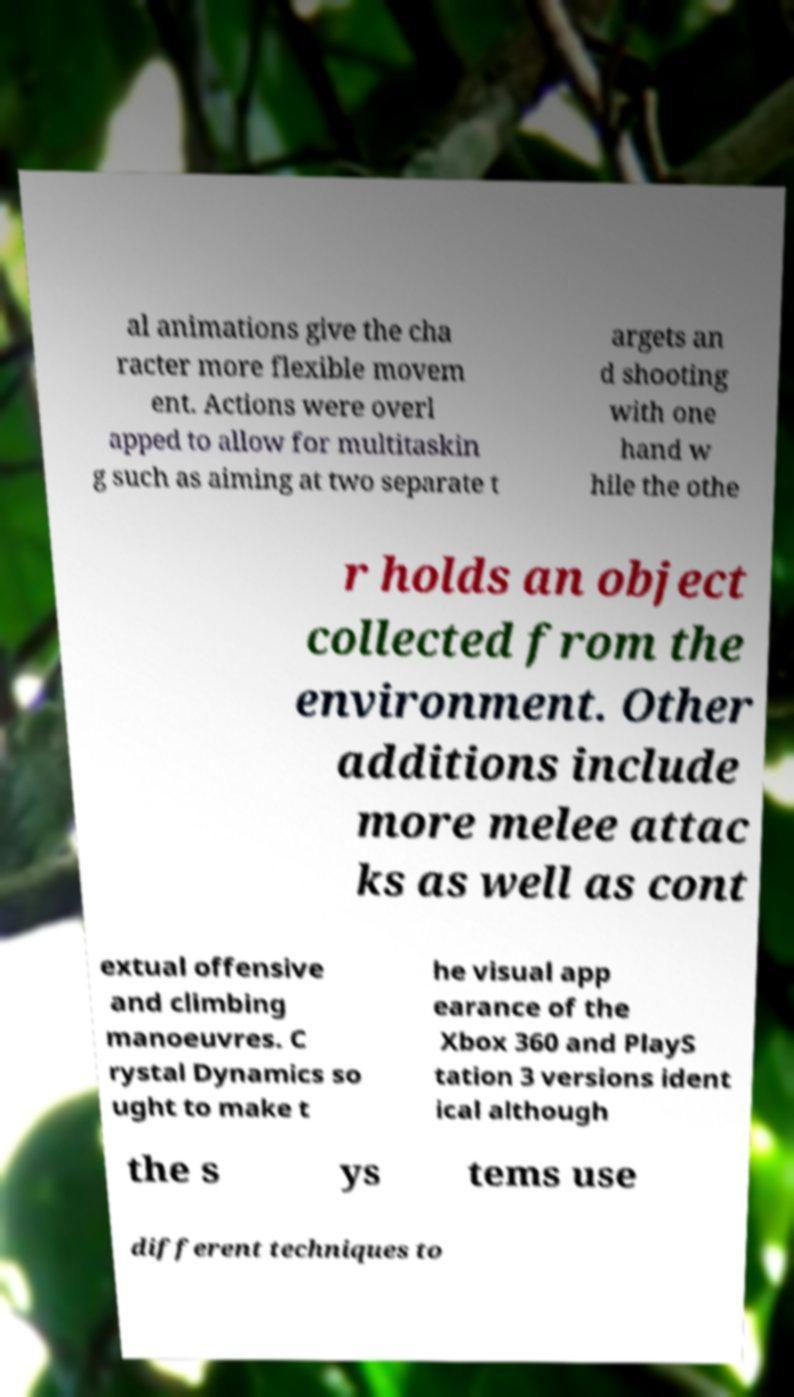Can you read and provide the text displayed in the image?This photo seems to have some interesting text. Can you extract and type it out for me? al animations give the cha racter more flexible movem ent. Actions were overl apped to allow for multitaskin g such as aiming at two separate t argets an d shooting with one hand w hile the othe r holds an object collected from the environment. Other additions include more melee attac ks as well as cont extual offensive and climbing manoeuvres. C rystal Dynamics so ught to make t he visual app earance of the Xbox 360 and PlayS tation 3 versions ident ical although the s ys tems use different techniques to 